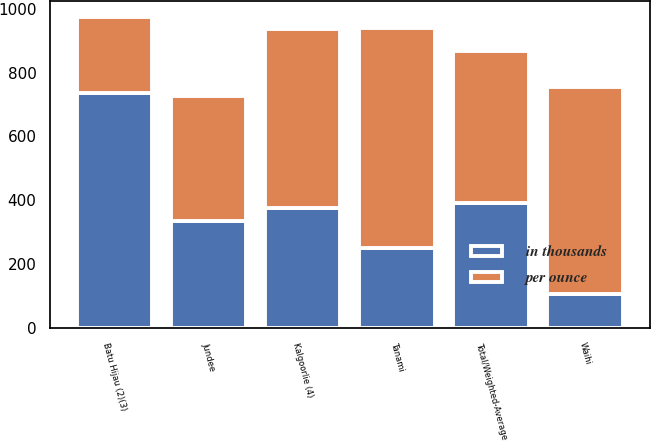<chart> <loc_0><loc_0><loc_500><loc_500><stacked_bar_chart><ecel><fcel>Batu Hijau (2)(3)<fcel>Kalgoorlie (4)<fcel>Jundee<fcel>Tanami<fcel>Waihi<fcel>Total/Weighted-Average<nl><fcel>in thousands<fcel>737<fcel>377<fcel>335<fcel>250<fcel>108<fcel>393<nl><fcel>per ounce<fcel>237<fcel>558<fcel>393<fcel>689<fcel>647<fcel>474<nl></chart> 